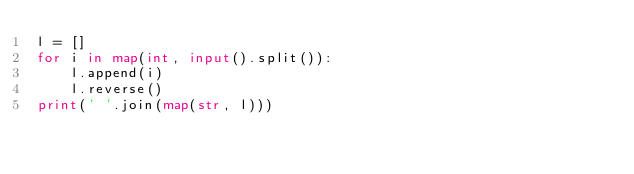Convert code to text. <code><loc_0><loc_0><loc_500><loc_500><_Python_>l = []
for i in map(int, input().split()):
    l.append(i)
    l.reverse()
print(' '.join(map(str, l)))
</code> 